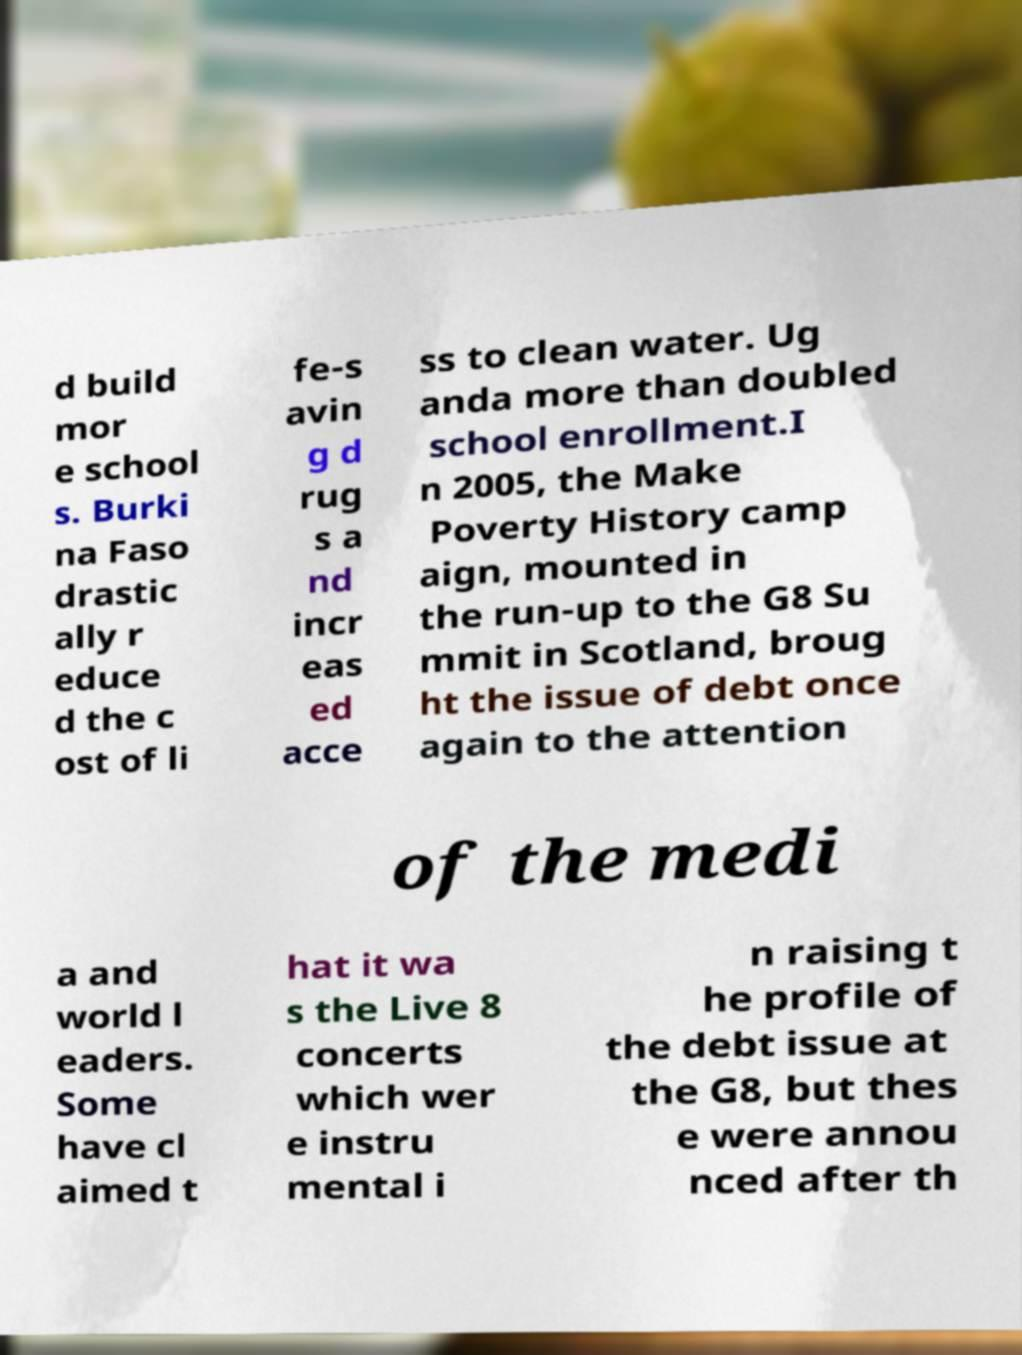Please read and relay the text visible in this image. What does it say? d build mor e school s. Burki na Faso drastic ally r educe d the c ost of li fe-s avin g d rug s a nd incr eas ed acce ss to clean water. Ug anda more than doubled school enrollment.I n 2005, the Make Poverty History camp aign, mounted in the run-up to the G8 Su mmit in Scotland, broug ht the issue of debt once again to the attention of the medi a and world l eaders. Some have cl aimed t hat it wa s the Live 8 concerts which wer e instru mental i n raising t he profile of the debt issue at the G8, but thes e were annou nced after th 